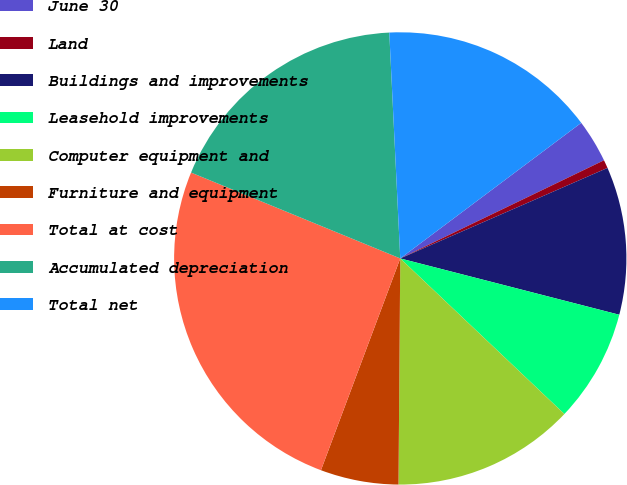Convert chart to OTSL. <chart><loc_0><loc_0><loc_500><loc_500><pie_chart><fcel>June 30<fcel>Land<fcel>Buildings and improvements<fcel>Leasehold improvements<fcel>Computer equipment and<fcel>Furniture and equipment<fcel>Total at cost<fcel>Accumulated depreciation<fcel>Total net<nl><fcel>3.09%<fcel>0.59%<fcel>10.56%<fcel>8.07%<fcel>13.05%<fcel>5.58%<fcel>25.5%<fcel>18.03%<fcel>15.54%<nl></chart> 